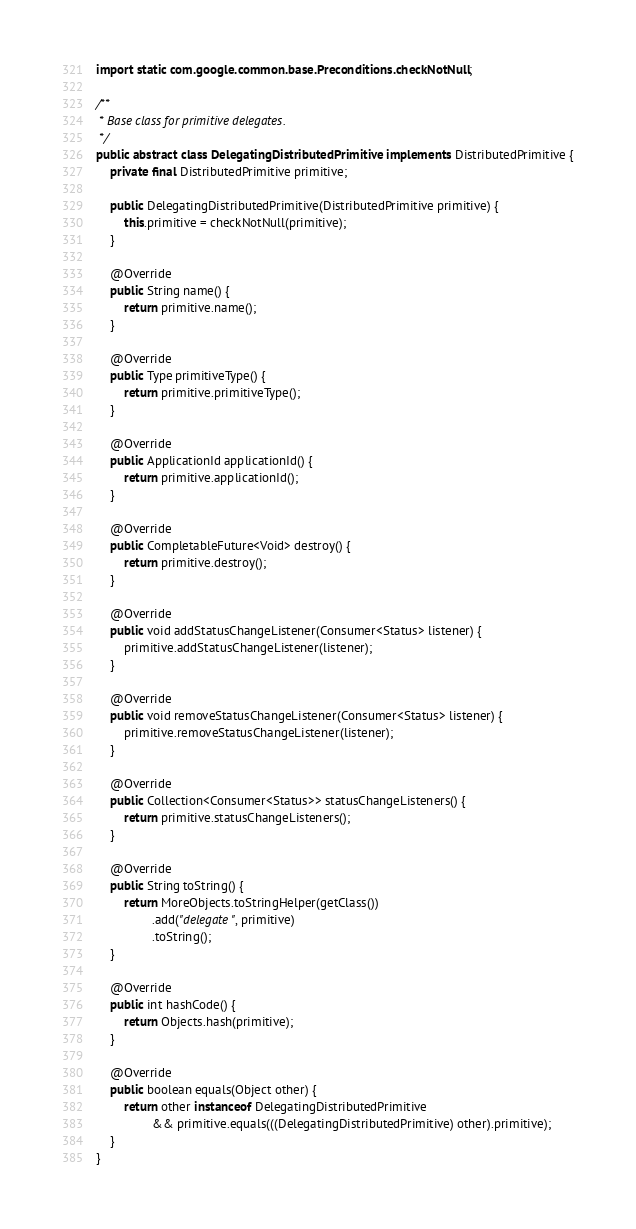<code> <loc_0><loc_0><loc_500><loc_500><_Java_>
import static com.google.common.base.Preconditions.checkNotNull;

/**
 * Base class for primitive delegates.
 */
public abstract class DelegatingDistributedPrimitive implements DistributedPrimitive {
    private final DistributedPrimitive primitive;

    public DelegatingDistributedPrimitive(DistributedPrimitive primitive) {
        this.primitive = checkNotNull(primitive);
    }

    @Override
    public String name() {
        return primitive.name();
    }

    @Override
    public Type primitiveType() {
        return primitive.primitiveType();
    }

    @Override
    public ApplicationId applicationId() {
        return primitive.applicationId();
    }

    @Override
    public CompletableFuture<Void> destroy() {
        return primitive.destroy();
    }

    @Override
    public void addStatusChangeListener(Consumer<Status> listener) {
        primitive.addStatusChangeListener(listener);
    }

    @Override
    public void removeStatusChangeListener(Consumer<Status> listener) {
        primitive.removeStatusChangeListener(listener);
    }

    @Override
    public Collection<Consumer<Status>> statusChangeListeners() {
        return primitive.statusChangeListeners();
    }

    @Override
    public String toString() {
        return MoreObjects.toStringHelper(getClass())
                .add("delegate", primitive)
                .toString();
    }

    @Override
    public int hashCode() {
        return Objects.hash(primitive);
    }

    @Override
    public boolean equals(Object other) {
        return other instanceof DelegatingDistributedPrimitive
                && primitive.equals(((DelegatingDistributedPrimitive) other).primitive);
    }
}
</code> 